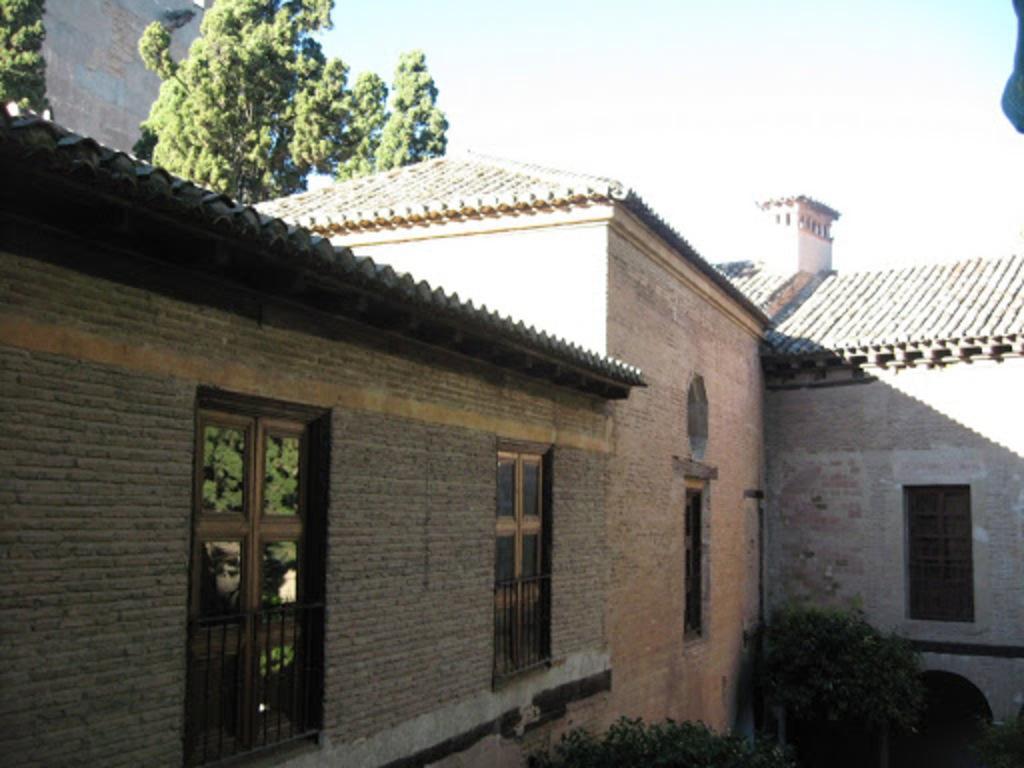In one or two sentences, can you explain what this image depicts? In this image I see a house and I see windows over here and I see the plants. In the background I see the sky and few trees over here. 